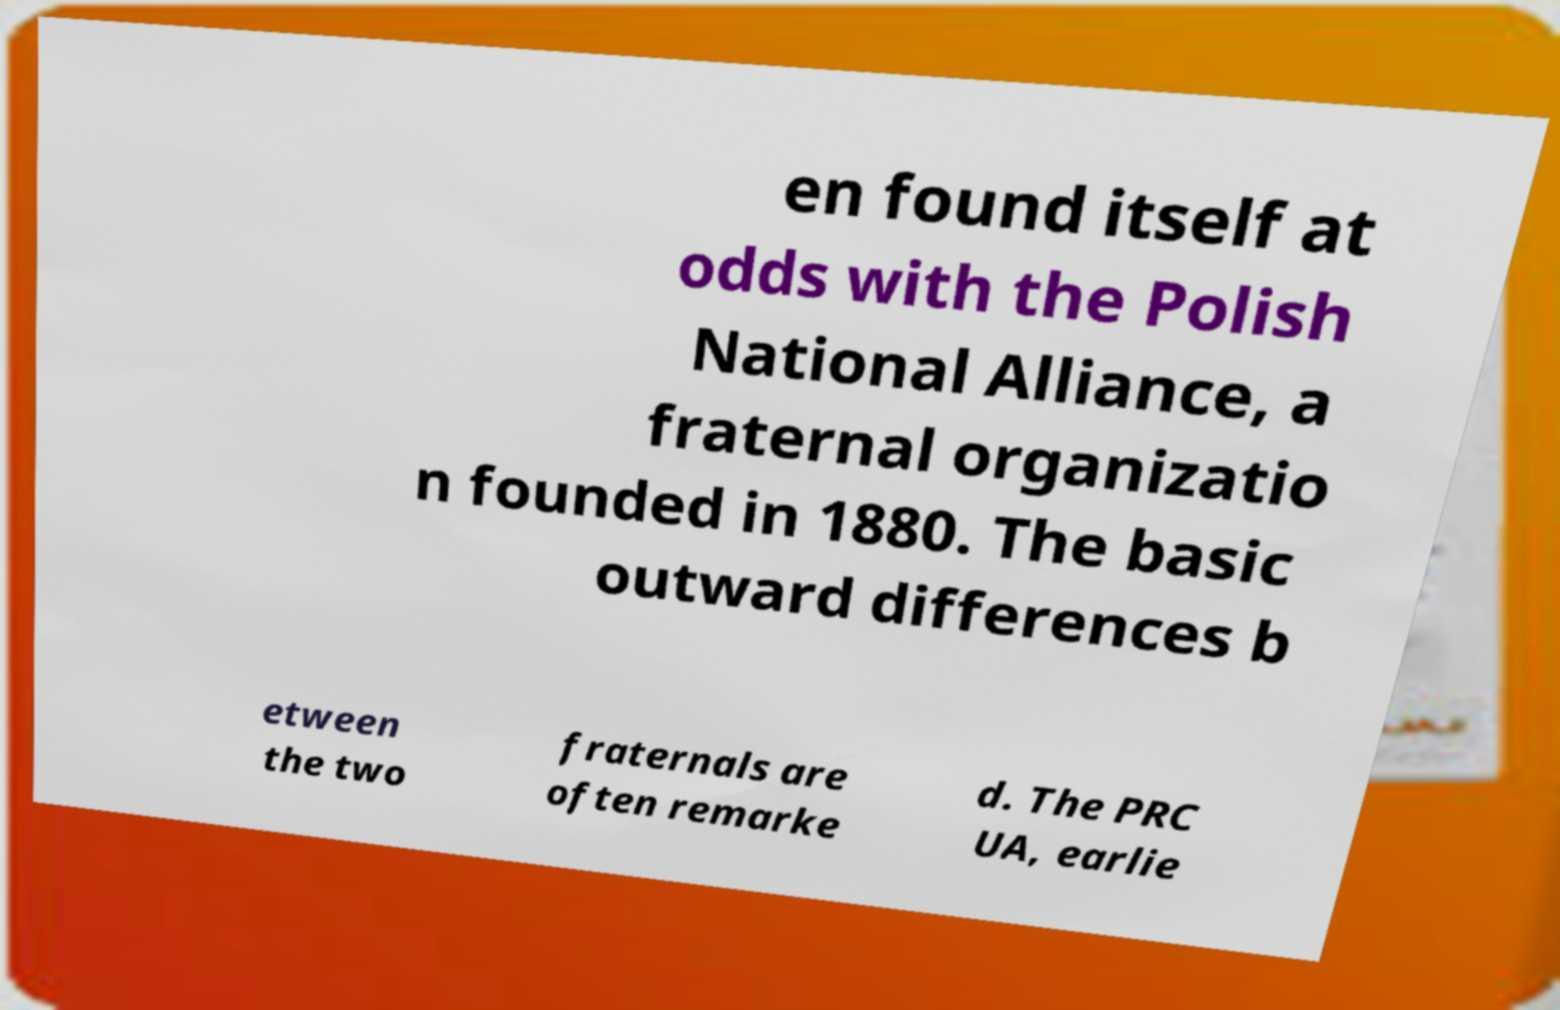What messages or text are displayed in this image? I need them in a readable, typed format. en found itself at odds with the Polish National Alliance, a fraternal organizatio n founded in 1880. The basic outward differences b etween the two fraternals are often remarke d. The PRC UA, earlie 